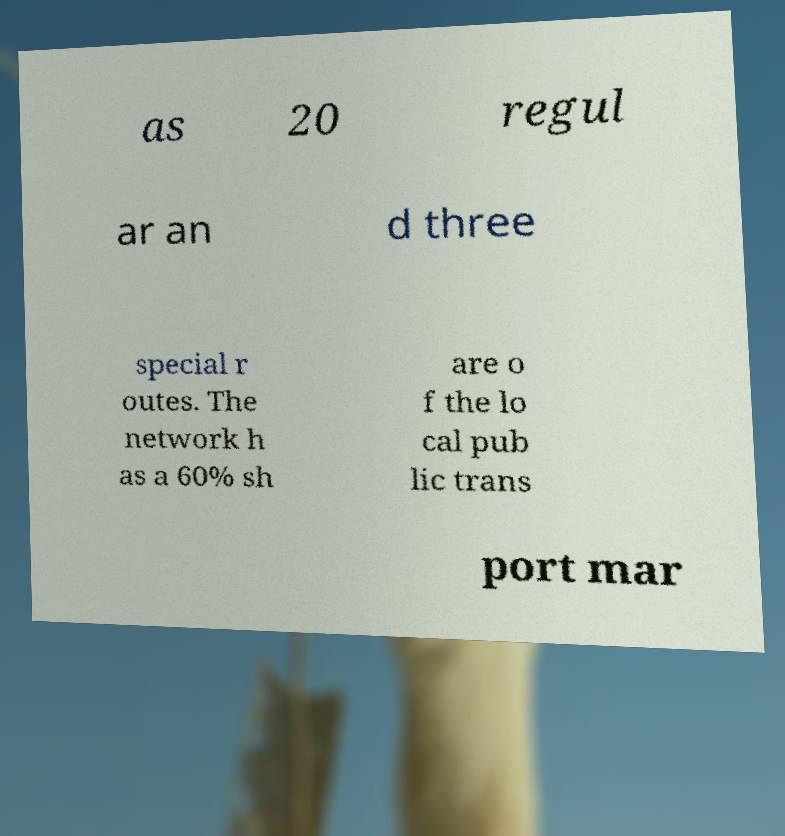Please read and relay the text visible in this image. What does it say? as 20 regul ar an d three special r outes. The network h as a 60% sh are o f the lo cal pub lic trans port mar 